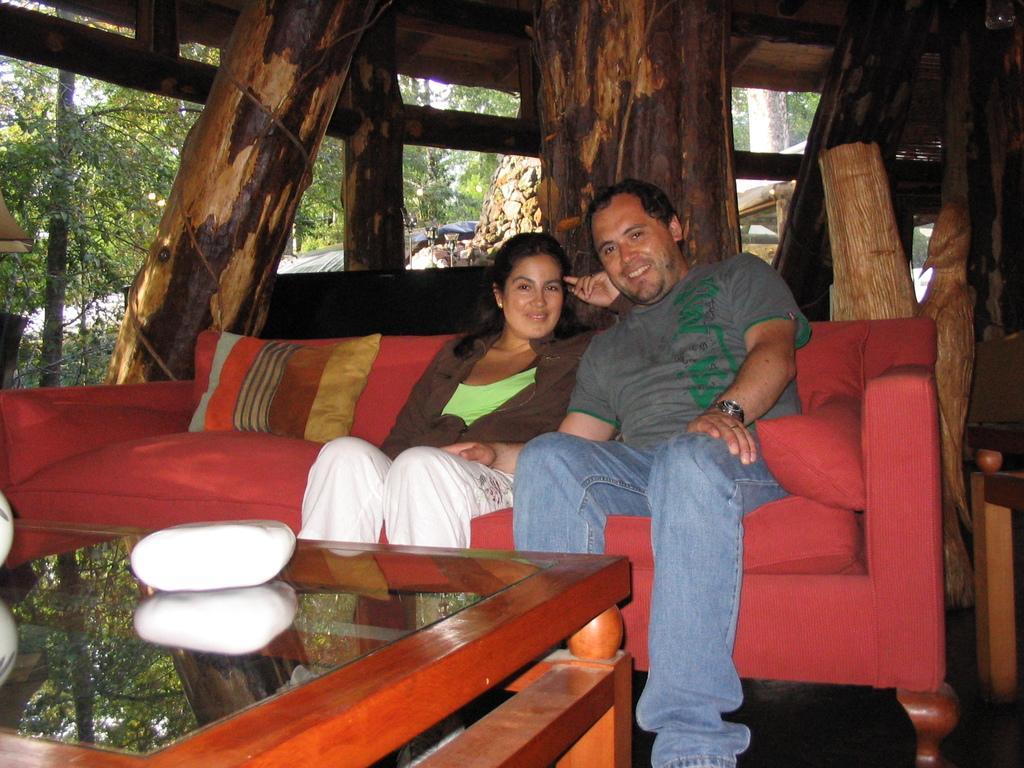Please provide a concise description of this image. It is an open area or lawn there is a red color sofa on which a man and woman are sitting both of them are laughing , in front of them there is a table behind them there are some wooden logs and in the background there are trees and sky. 